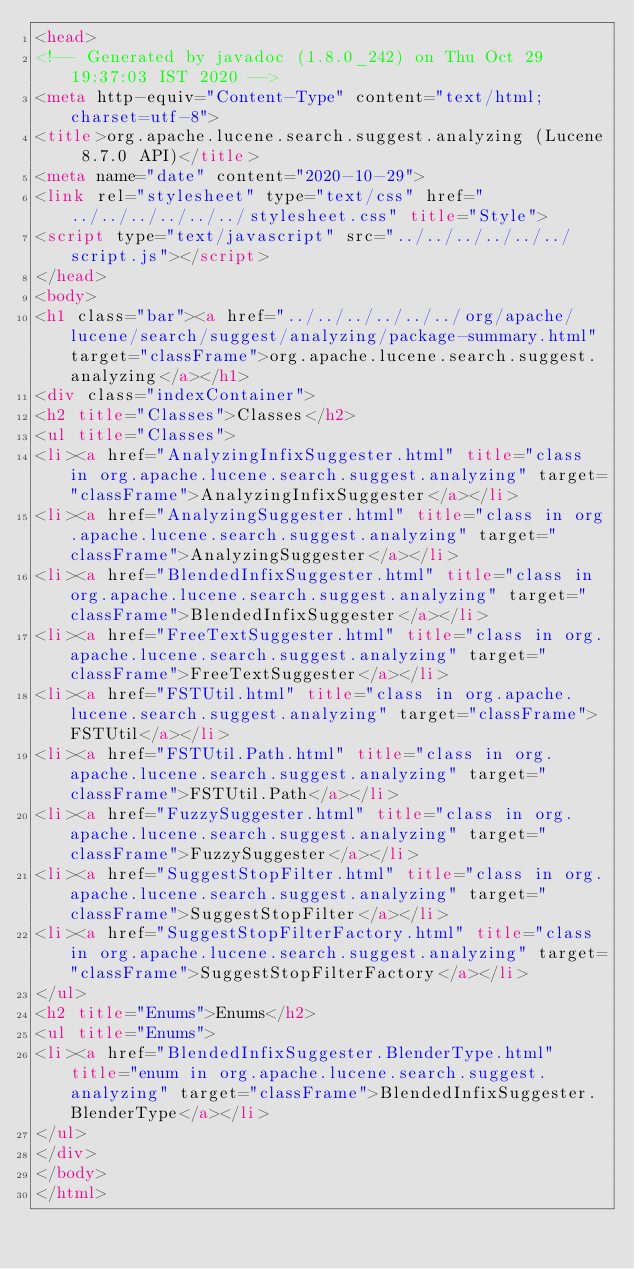<code> <loc_0><loc_0><loc_500><loc_500><_HTML_><head>
<!-- Generated by javadoc (1.8.0_242) on Thu Oct 29 19:37:03 IST 2020 -->
<meta http-equiv="Content-Type" content="text/html; charset=utf-8">
<title>org.apache.lucene.search.suggest.analyzing (Lucene 8.7.0 API)</title>
<meta name="date" content="2020-10-29">
<link rel="stylesheet" type="text/css" href="../../../../../../stylesheet.css" title="Style">
<script type="text/javascript" src="../../../../../../script.js"></script>
</head>
<body>
<h1 class="bar"><a href="../../../../../../org/apache/lucene/search/suggest/analyzing/package-summary.html" target="classFrame">org.apache.lucene.search.suggest.analyzing</a></h1>
<div class="indexContainer">
<h2 title="Classes">Classes</h2>
<ul title="Classes">
<li><a href="AnalyzingInfixSuggester.html" title="class in org.apache.lucene.search.suggest.analyzing" target="classFrame">AnalyzingInfixSuggester</a></li>
<li><a href="AnalyzingSuggester.html" title="class in org.apache.lucene.search.suggest.analyzing" target="classFrame">AnalyzingSuggester</a></li>
<li><a href="BlendedInfixSuggester.html" title="class in org.apache.lucene.search.suggest.analyzing" target="classFrame">BlendedInfixSuggester</a></li>
<li><a href="FreeTextSuggester.html" title="class in org.apache.lucene.search.suggest.analyzing" target="classFrame">FreeTextSuggester</a></li>
<li><a href="FSTUtil.html" title="class in org.apache.lucene.search.suggest.analyzing" target="classFrame">FSTUtil</a></li>
<li><a href="FSTUtil.Path.html" title="class in org.apache.lucene.search.suggest.analyzing" target="classFrame">FSTUtil.Path</a></li>
<li><a href="FuzzySuggester.html" title="class in org.apache.lucene.search.suggest.analyzing" target="classFrame">FuzzySuggester</a></li>
<li><a href="SuggestStopFilter.html" title="class in org.apache.lucene.search.suggest.analyzing" target="classFrame">SuggestStopFilter</a></li>
<li><a href="SuggestStopFilterFactory.html" title="class in org.apache.lucene.search.suggest.analyzing" target="classFrame">SuggestStopFilterFactory</a></li>
</ul>
<h2 title="Enums">Enums</h2>
<ul title="Enums">
<li><a href="BlendedInfixSuggester.BlenderType.html" title="enum in org.apache.lucene.search.suggest.analyzing" target="classFrame">BlendedInfixSuggester.BlenderType</a></li>
</ul>
</div>
</body>
</html>
</code> 